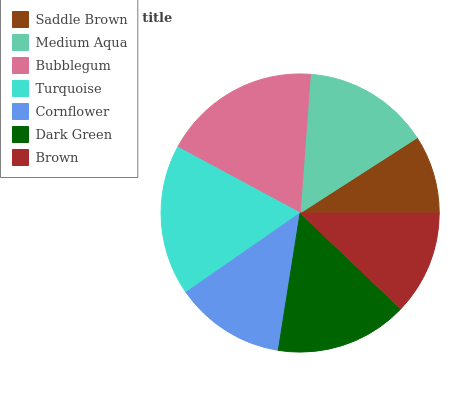Is Saddle Brown the minimum?
Answer yes or no. Yes. Is Bubblegum the maximum?
Answer yes or no. Yes. Is Medium Aqua the minimum?
Answer yes or no. No. Is Medium Aqua the maximum?
Answer yes or no. No. Is Medium Aqua greater than Saddle Brown?
Answer yes or no. Yes. Is Saddle Brown less than Medium Aqua?
Answer yes or no. Yes. Is Saddle Brown greater than Medium Aqua?
Answer yes or no. No. Is Medium Aqua less than Saddle Brown?
Answer yes or no. No. Is Medium Aqua the high median?
Answer yes or no. Yes. Is Medium Aqua the low median?
Answer yes or no. Yes. Is Turquoise the high median?
Answer yes or no. No. Is Bubblegum the low median?
Answer yes or no. No. 